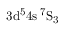Convert formula to latex. <formula><loc_0><loc_0><loc_500><loc_500>3 d ^ { 5 } 4 s \, ^ { 7 } S _ { 3 }</formula> 